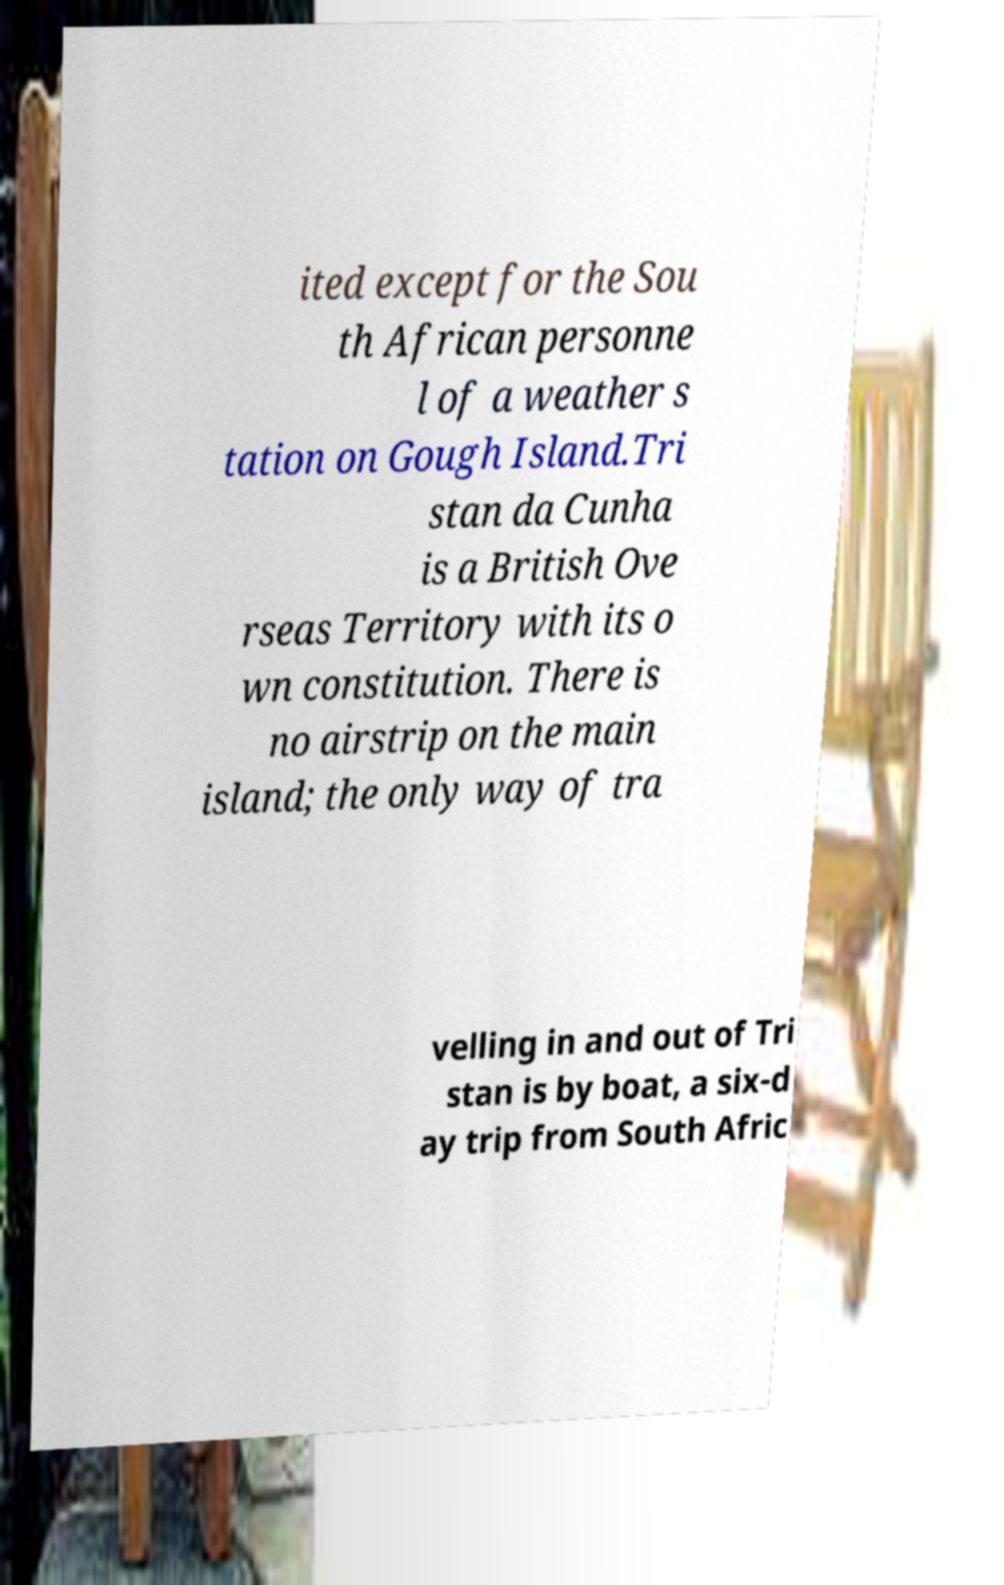Could you extract and type out the text from this image? ited except for the Sou th African personne l of a weather s tation on Gough Island.Tri stan da Cunha is a British Ove rseas Territory with its o wn constitution. There is no airstrip on the main island; the only way of tra velling in and out of Tri stan is by boat, a six-d ay trip from South Afric 